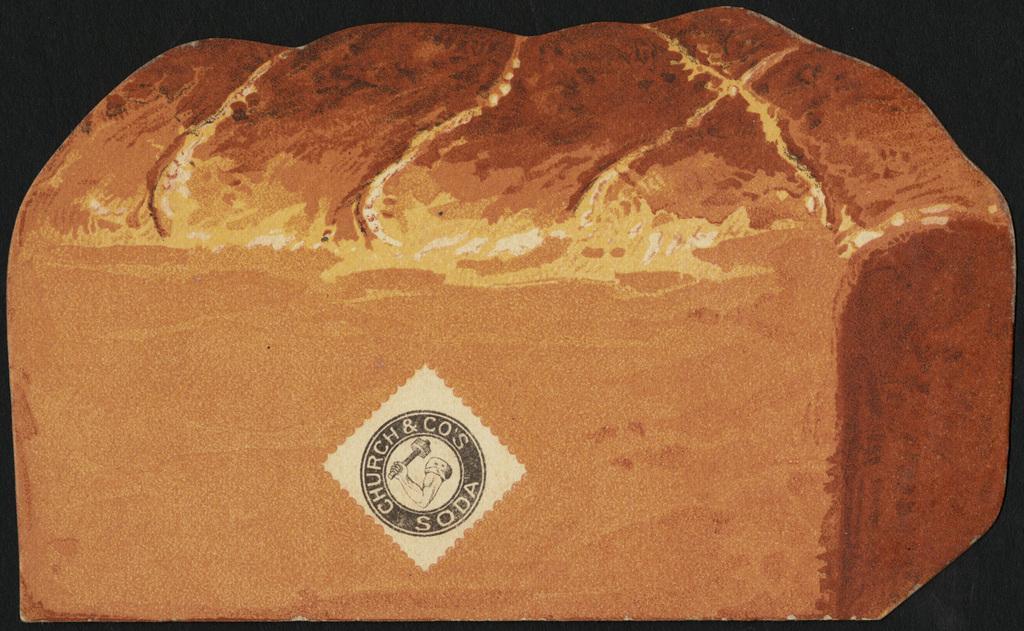Can you describe this image briefly? In this picture we can see a sticker on an object and in the background it is dark. 